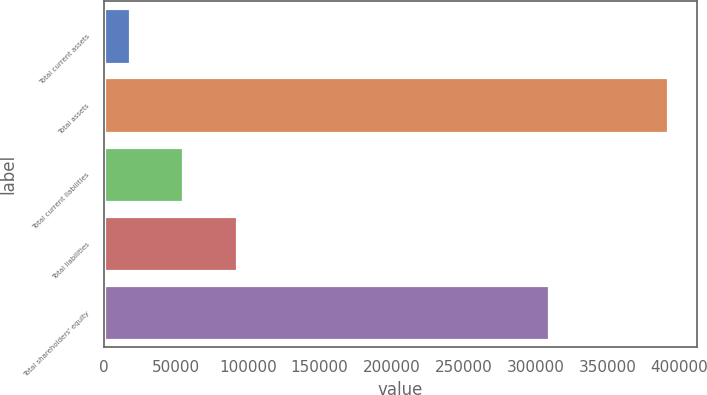Convert chart to OTSL. <chart><loc_0><loc_0><loc_500><loc_500><bar_chart><fcel>Total current assets<fcel>Total assets<fcel>Total current liabilities<fcel>Total liabilities<fcel>Total shareholders' equity<nl><fcel>17824<fcel>392495<fcel>55291.1<fcel>92758.2<fcel>309354<nl></chart> 